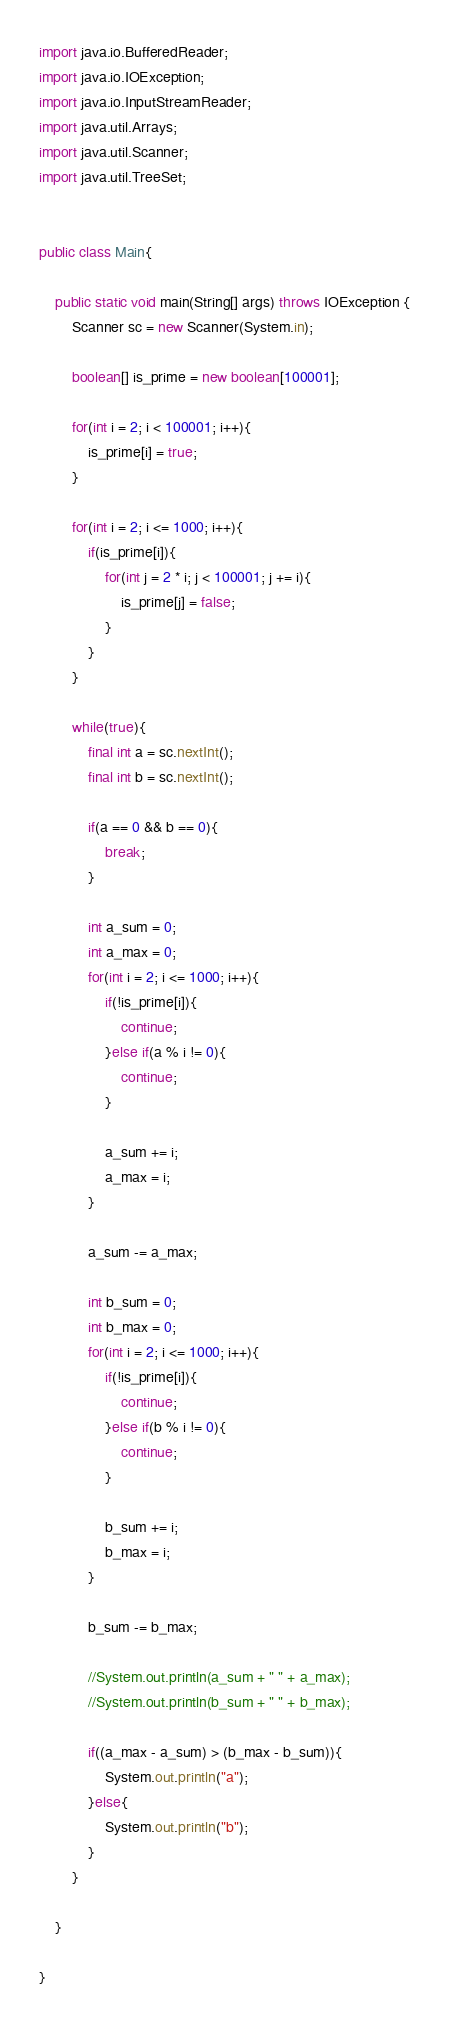<code> <loc_0><loc_0><loc_500><loc_500><_Java_>import java.io.BufferedReader;
import java.io.IOException;
import java.io.InputStreamReader;
import java.util.Arrays;
import java.util.Scanner;
import java.util.TreeSet;
 
 
public class Main{
     
    public static void main(String[] args) throws IOException {
    	Scanner sc = new Scanner(System.in);
    	
    	boolean[] is_prime = new boolean[100001];
    	
    	for(int i = 2; i < 100001; i++){
    		is_prime[i] = true;
    	}
    	
    	for(int i = 2; i <= 1000; i++){
    		if(is_prime[i]){
    			for(int j = 2 * i; j < 100001; j += i){
    				is_prime[j] = false;
    			}
    		}
    	}
    	
    	while(true){
    		final int a = sc.nextInt();
    		final int b = sc.nextInt();
    		
    		if(a == 0 && b == 0){
    			break;
    		}
    		
    		int a_sum = 0;
    		int a_max = 0;
    		for(int i = 2; i <= 1000; i++){
    			if(!is_prime[i]){
    				continue;
    			}else if(a % i != 0){
    				continue;
    			}
    			
    			a_sum += i;
    			a_max = i;
    		}
    		
    		a_sum -= a_max;
    		
    		int b_sum = 0;
    		int b_max = 0;
    		for(int i = 2; i <= 1000; i++){
    			if(!is_prime[i]){
    				continue;
    			}else if(b % i != 0){
    				continue;
    			}
    			
    			b_sum += i;
    			b_max = i;
    		}
    		
    		b_sum -= b_max;
    		
    		//System.out.println(a_sum + " " + a_max);
    		//System.out.println(b_sum + " " + b_max);
    		
    		if((a_max - a_sum) > (b_max - b_sum)){
    			System.out.println("a");
    		}else{
    			System.out.println("b");
    		}
    	}
        
    }
     
}</code> 